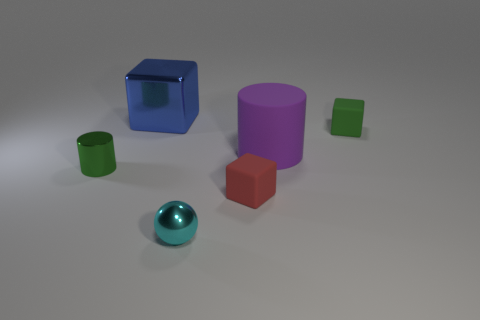Subtract all big blue blocks. How many blocks are left? 2 Add 2 tiny matte cylinders. How many objects exist? 8 Subtract all spheres. How many objects are left? 5 Subtract all gray cubes. Subtract all purple cylinders. How many cubes are left? 3 Add 1 large purple things. How many large purple things are left? 2 Add 1 matte blocks. How many matte blocks exist? 3 Subtract 0 yellow blocks. How many objects are left? 6 Subtract all cyan metal things. Subtract all tiny cyan metallic objects. How many objects are left? 4 